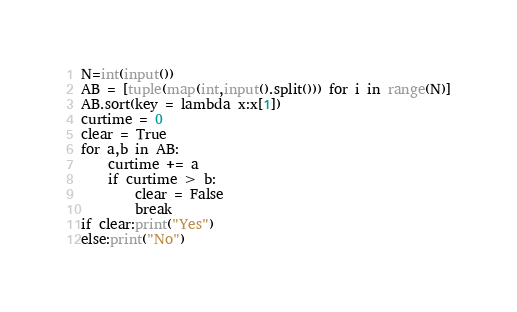<code> <loc_0><loc_0><loc_500><loc_500><_Python_>N=int(input())
AB = [tuple(map(int,input().split())) for i in range(N)]
AB.sort(key = lambda x:x[1])
curtime = 0
clear = True
for a,b in AB:
    curtime += a
    if curtime > b:
        clear = False
        break
if clear:print("Yes")
else:print("No")</code> 